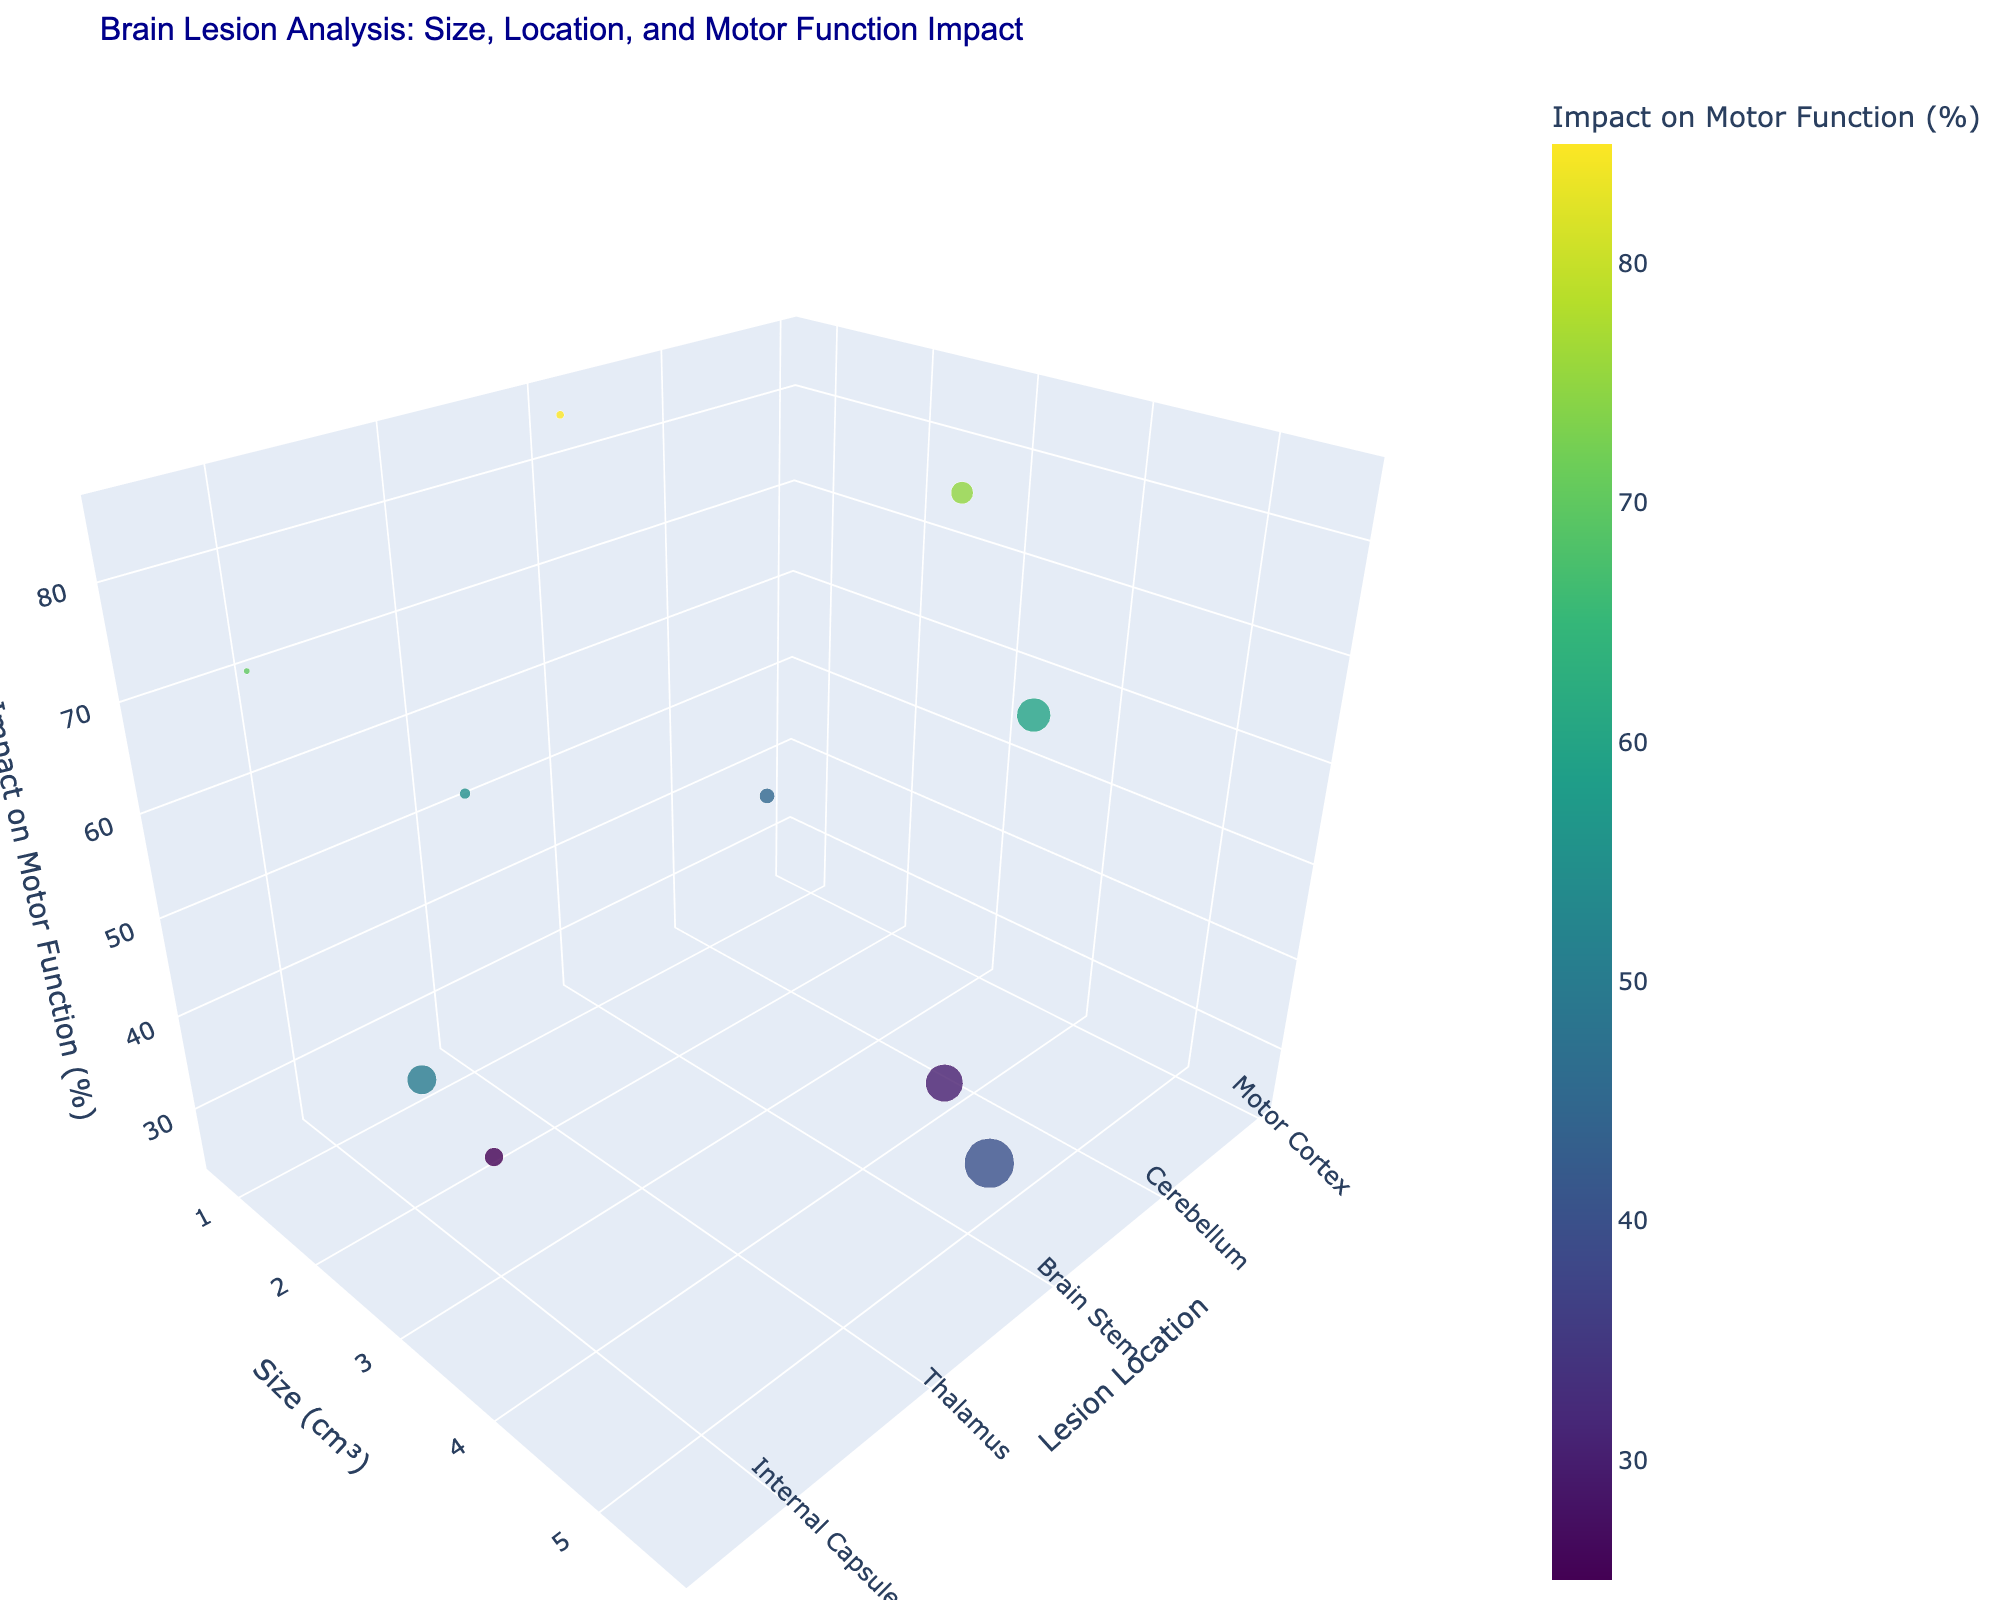What is the title of the figure? The figure's title is displayed prominently at the top and serves to provide an overview of the data being presented. The title reads "Brain Lesion Analysis: Size, Location, and Motor Function Impact".
Answer: Brain Lesion Analysis: Size, Location, and Motor Function Impact Which lesion location has the smallest size? By examining the y-axis, which represents the size in cm³, we find that "Internal Capsule" has the smallest size bubble, indicating it has the smallest lesion size at 0.7 cm³.
Answer: Internal Capsule What is the impact on motor function for lesions in the Premotor Cortex? By identifying the "Premotor Cortex" on the x-axis and then checking the z-axis value corresponding to this point, we see that the impact on motor function is 50%.
Answer: 50% Among Ischemic Stroke and Hemorrhagic Stroke, which has a larger lesion size? By locating "Ischemic Stroke" in the "Motor Cortex" and "Hemorrhagic Stroke" in the "Basal Ganglia" on the x-axis, then comparing their respective y-axis values, Hemorrhagic Stroke has a larger lesion size of 3.8 cm³ compared to 2.5 cm³ of Ischemic Stroke.
Answer: Hemorrhagic Stroke What is the total lesion size for Cerebellum and Thalamus? Identify the lesion sizes for "Cerebellum" and "Thalamus" on the y-axis: 1.7 cm³ and 1.2 cm³, respectively. Sum them to find the total size: 1.7 + 1.2 = 2.9 cm³.
Answer: 2.9 cm³ Which lesion has the highest impact on motor function? Examine the z-axis for the highest percentage value. The highest value is 85%, corresponding to the "Brain Stem" lesion location.
Answer: Brain Stem What is the average impact on motor function for Basal Ganglia, Frontal Lobe, and Thalamus? Extract impact percentages: 60% (Basal Ganglia), 40% (Frontal Lobe), and 55% (Thalamus). Calculate the average by summing and dividing by 3: (60 + 40 + 55) / 3 = 51.67%.
Answer: 51.67% How many injury types are represented in the figure? By reviewing the text labels or data points, we see that each injury type appears once. The count of unique injury types (Ischemic Stroke, Hemorrhagic Stroke, Traumatic Brain Injury, etc.) sums to 10.
Answer: 10 Which has a greater impact on motor function: Internal Capsule or Corpus Callosum? Check the z-axis values for "Internal Capsule" and "Corpus Callosum". The impact for Internal Capsule is 70%, while for Corpus Callosum it is 25%. Thus, Internal Capsule has the greater impact.
Answer: Internal Capsule 